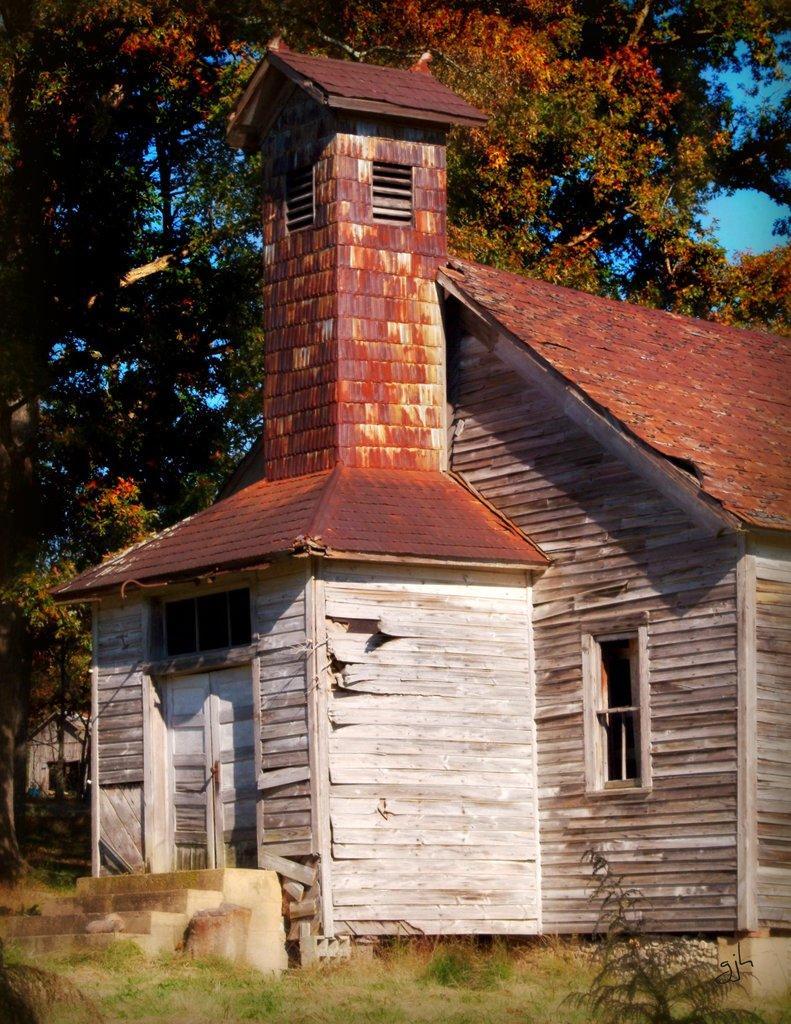Describe this image in one or two sentences. In this picture we can see the grass, house, steps, trees and in the background we can see the sky. 